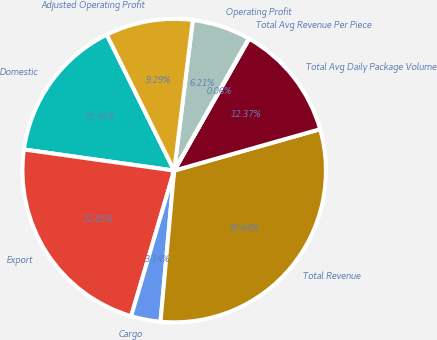Convert chart to OTSL. <chart><loc_0><loc_0><loc_500><loc_500><pie_chart><fcel>Domestic<fcel>Export<fcel>Cargo<fcel>Total Revenue<fcel>Total Avg Daily Package Volume<fcel>Total Avg Revenue Per Piece<fcel>Operating Profit<fcel>Adjusted Operating Profit<nl><fcel>15.45%<fcel>22.65%<fcel>3.14%<fcel>30.84%<fcel>12.37%<fcel>0.06%<fcel>6.21%<fcel>9.29%<nl></chart> 